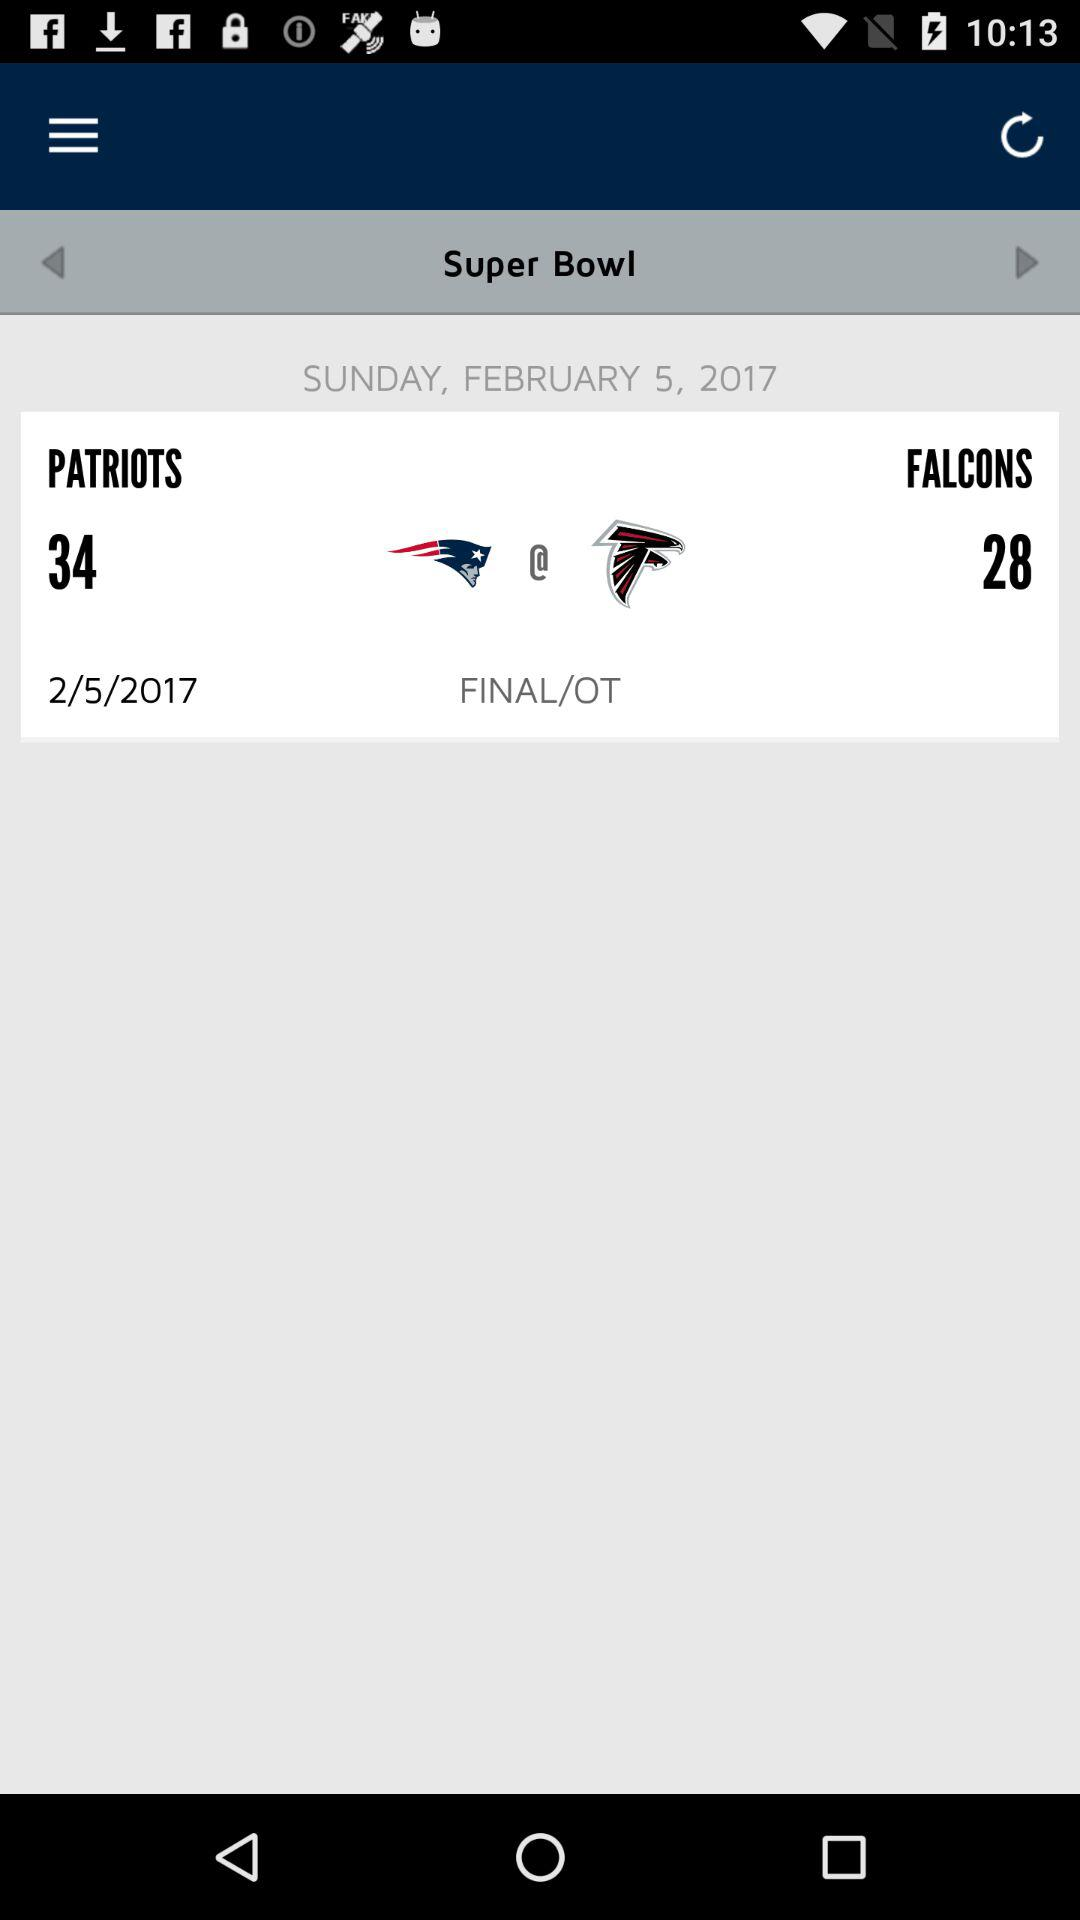How many more touchdowns did the Patriots score than the Falcons?
Answer the question using a single word or phrase. 6 